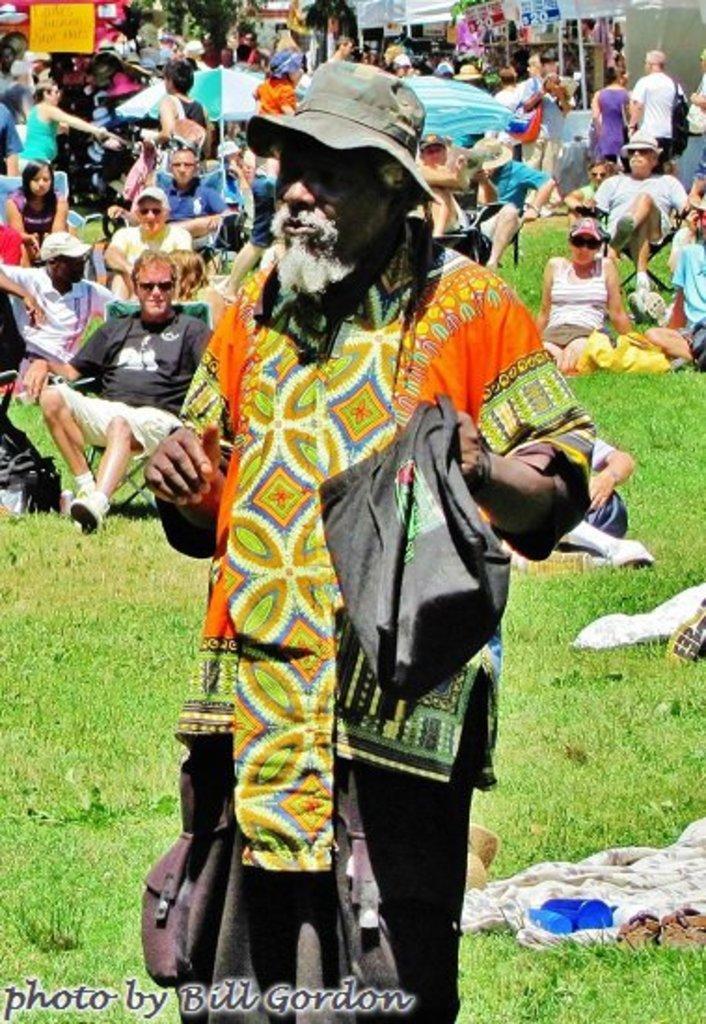In one or two sentences, can you explain what this image depicts? This picture is clicked outside. In the foreground we can see a man holding an object and standing on the ground and we can see there are some objects lying on the ground and we can see the green grass, group of people sitting on the chairs, group of people sitting on the ground and we can see the group of people seems to be standing on the ground. In the background we can see the trees, text on the posters, tents and some objects. In the bottom left corner we can see a watermark on the image. 